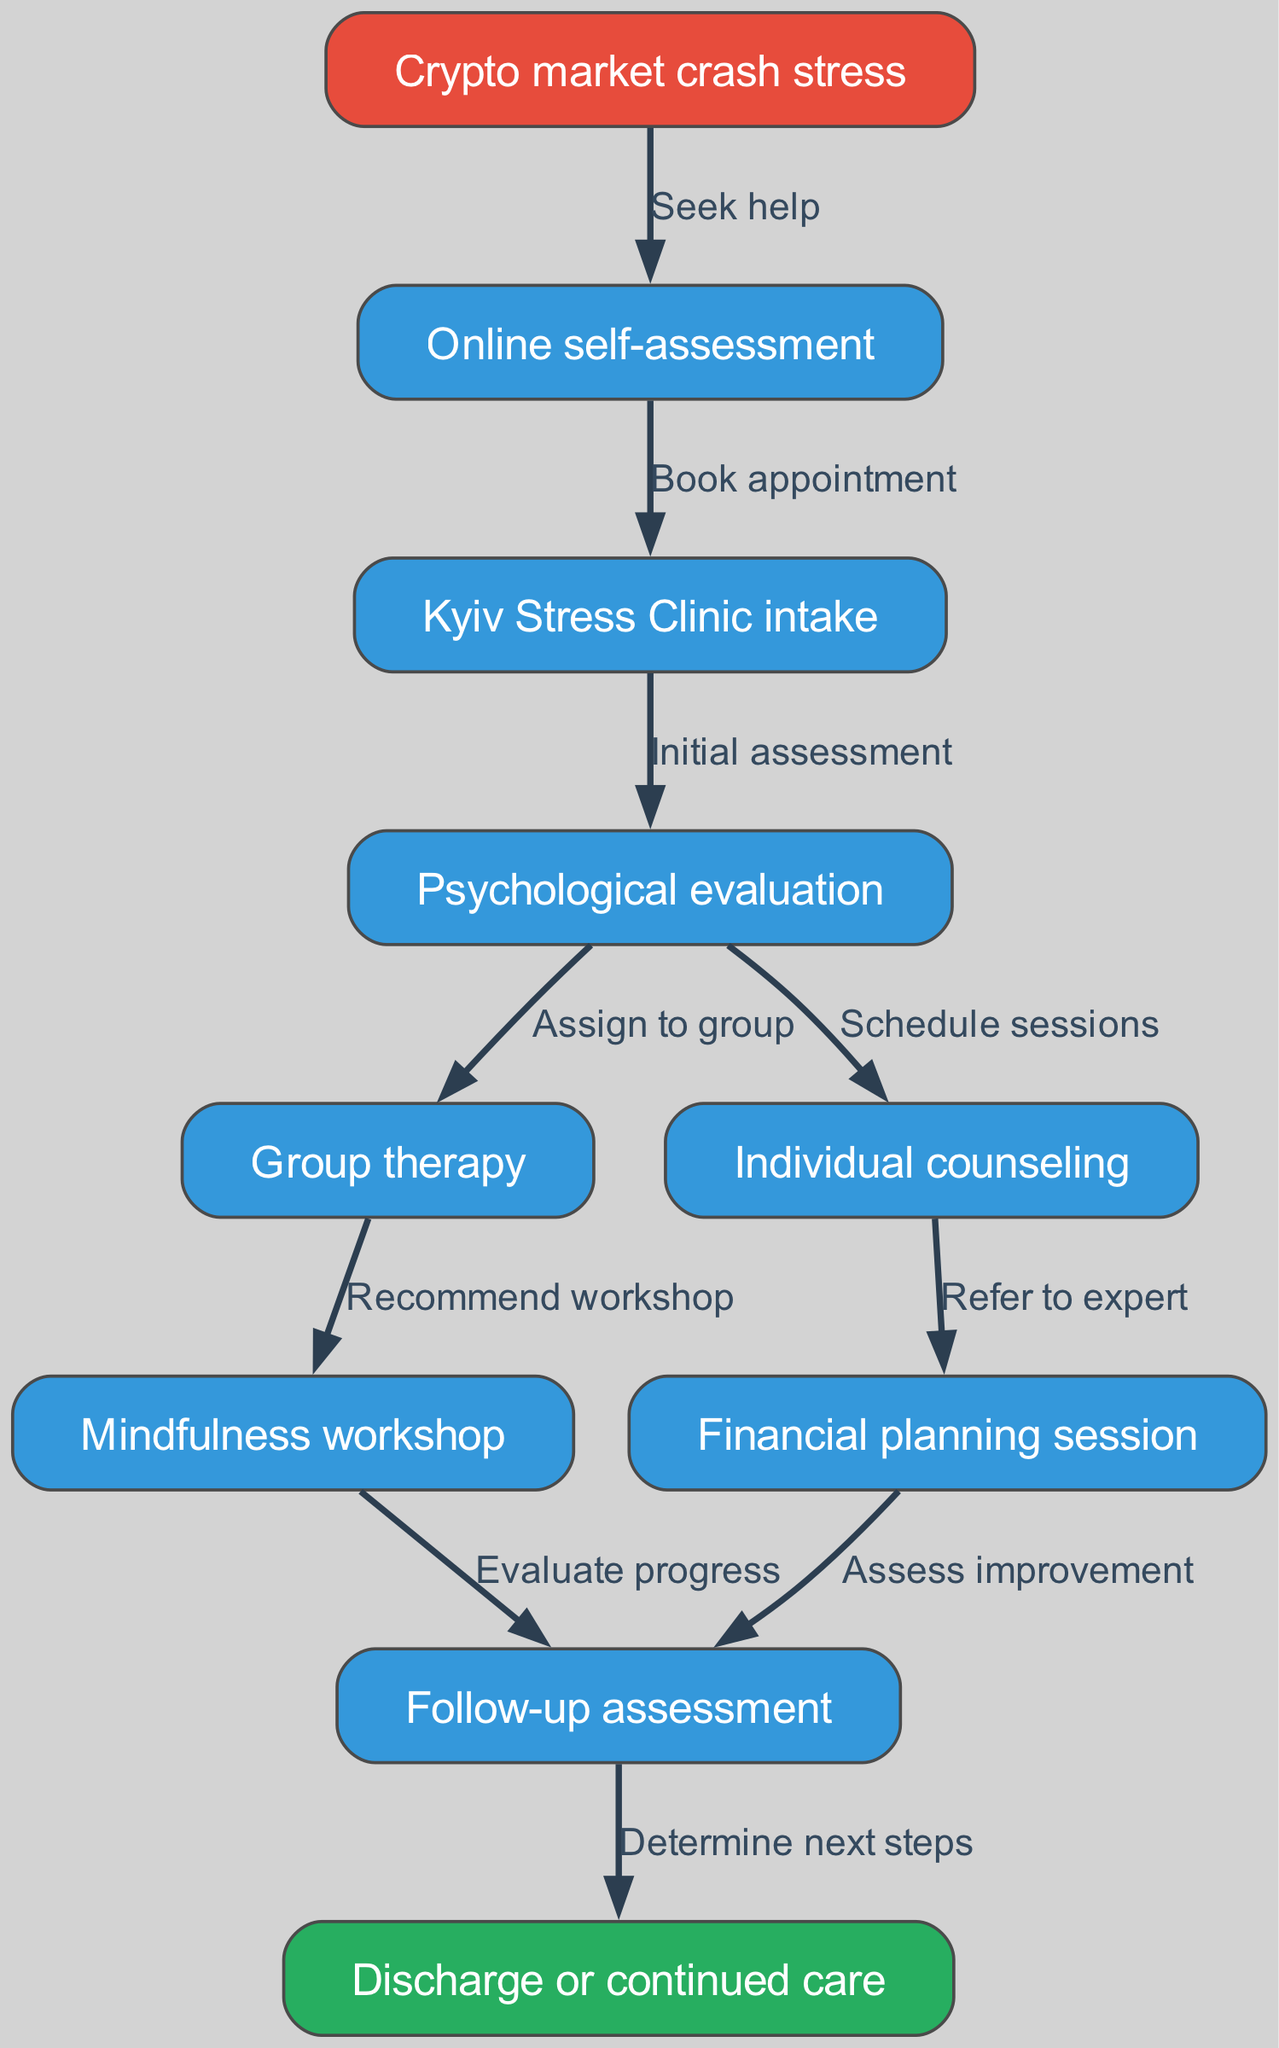What is the starting point of the patient journey in the diagram? The diagram shows that the starting point is "Crypto market crash stress," which is the first node indicating the stress that prompts individuals to seek help.
Answer: Crypto market crash stress How many nodes are in the diagram? By counting all the unique nodes listed in the data, there are ten nodes in total representing different stages of the patient journey.
Answer: 10 What is the outcome after the "Follow-up assessment"? Referring to the last edge in the diagram, the outcome after the "Follow-up assessment" is either "Discharge or continued care", indicating the patient's next steps based on their progress.
Answer: Discharge or continued care How many edges connect the "Psychological evaluation" node? Looking at the edges connected to the "Psychological evaluation" node, there are two edges: one leading to "Group therapy" and another to "Individual counseling," which shows the possible paths after evaluation.
Answer: 2 Which node follows directly after "Mindfulness workshop"? The diagram indicates that the "Mindfulness workshop" directly leads to "Follow-up assessment," indicating the next step after participating in the workshop.
Answer: Follow-up assessment What is the purpose of the "Financial planning session"? The node labeled "Financial planning session" is connected to the "Individual counseling" node, where it implies that it is a recommended follow-up to address financial issues related to stress management.
Answer: Refer to expert What action does a patient take after experiencing stress from the crypto market? The initial action derived from the diagram is to "Seek help" after facing stress, which connects the first node to the self-assessment process.
Answer: Seek help What connects the "Group therapy" and "Mindfulness workshop" nodes in the pathway? The connection between "Group therapy" and "Mindfulness workshop" is established through a recommendation made in the treatment process, indicating a sequence of therapies suggested for stress management.
Answer: Recommend workshop What evaluation follows the "Mindfulness workshop"? Following the "Mindfulness workshop," the next evaluation that occurs is the "Follow-up assessment," where progress is evaluated after the patient has engaged in the workshop.
Answer: Evaluate progress 